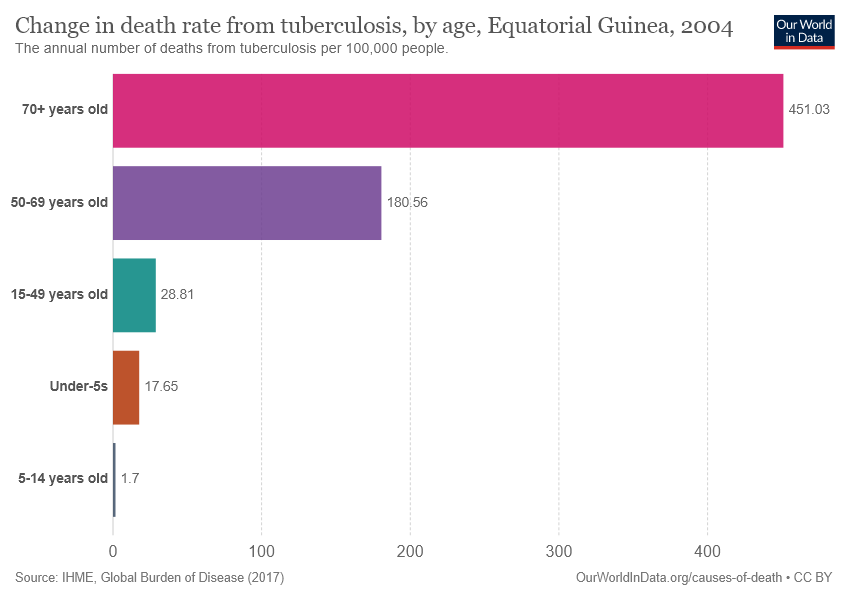Specify some key components in this picture. Approximately 180.56 deaths per 1,00,000 people in the age group of 50-69 years old are caused by tuberculosis each year. The difference between the largest value and the median of all values is 422.22. 